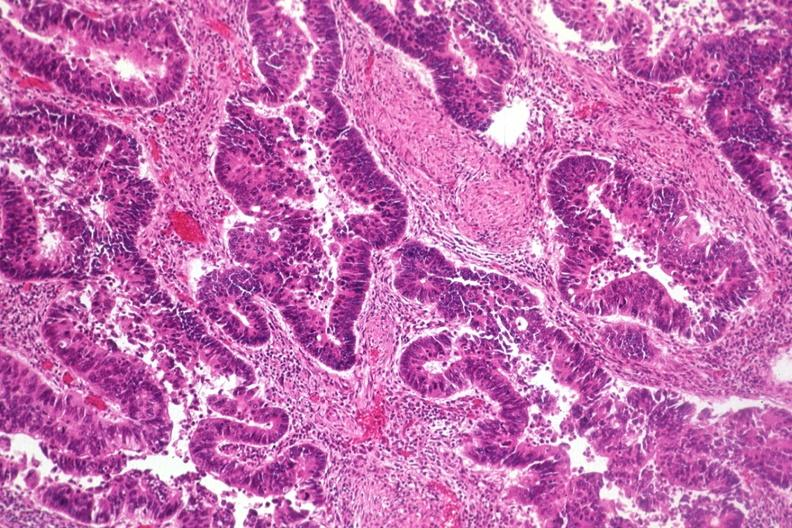what is present?
Answer the question using a single word or phrase. Gastrointestinal 